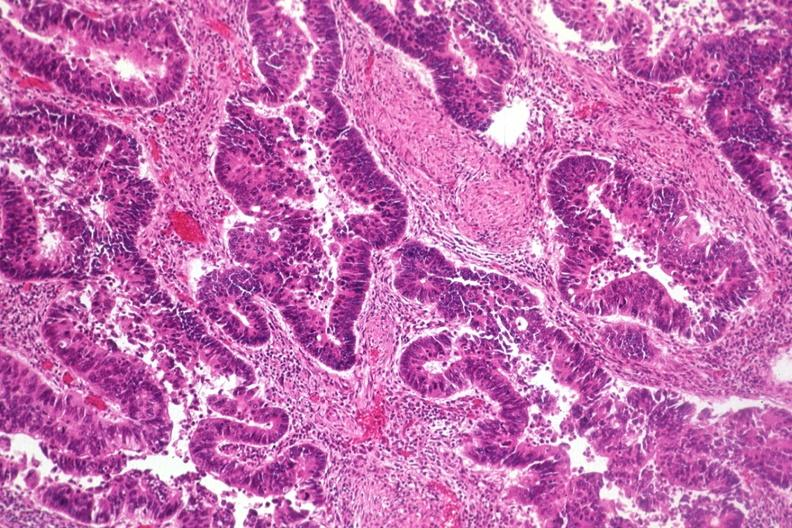what is present?
Answer the question using a single word or phrase. Gastrointestinal 